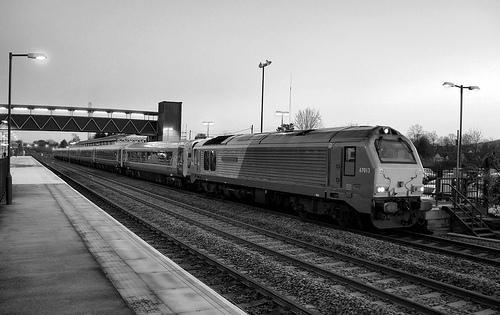How many cars on the train?
Give a very brief answer. 5. 